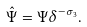<formula> <loc_0><loc_0><loc_500><loc_500>\hat { \Psi } = \Psi \delta ^ { - \sigma _ { 3 } } .</formula> 